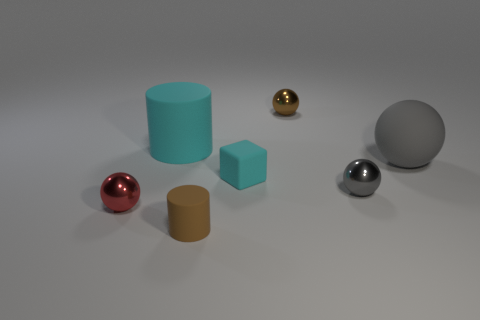Add 2 blocks. How many objects exist? 9 Subtract all metal balls. How many balls are left? 1 Subtract 0 gray cylinders. How many objects are left? 7 Subtract all cylinders. How many objects are left? 5 Subtract 2 cylinders. How many cylinders are left? 0 Subtract all purple cylinders. Subtract all purple blocks. How many cylinders are left? 2 Subtract all brown spheres. How many cyan cylinders are left? 1 Subtract all red shiny objects. Subtract all cyan blocks. How many objects are left? 5 Add 3 cylinders. How many cylinders are left? 5 Add 4 large cyan metal objects. How many large cyan metal objects exist? 4 